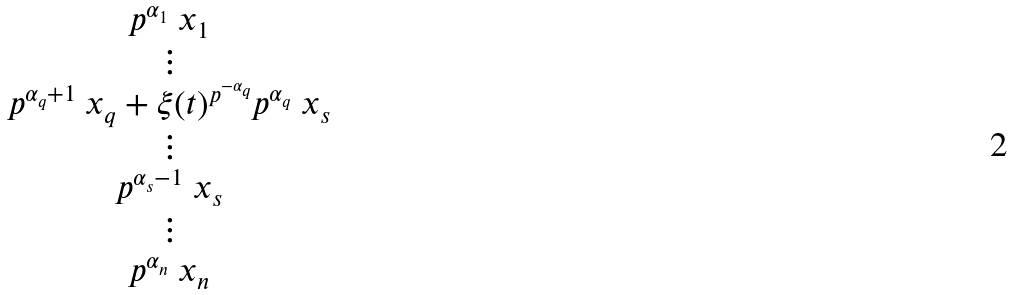<formula> <loc_0><loc_0><loc_500><loc_500>\begin{matrix} p ^ { \alpha _ { 1 } } \ x _ { 1 } \\ \vdots \\ p ^ { \alpha _ { q } + 1 } \ x _ { q } + \xi ( t ) ^ { p ^ { - \alpha _ { q } } } p ^ { \alpha _ { q } } \ x _ { s } \\ \vdots \\ p ^ { \alpha _ { s } - 1 } \ x _ { s } \\ \vdots \\ p ^ { \alpha _ { n } } \ x _ { n } \end{matrix}</formula> 